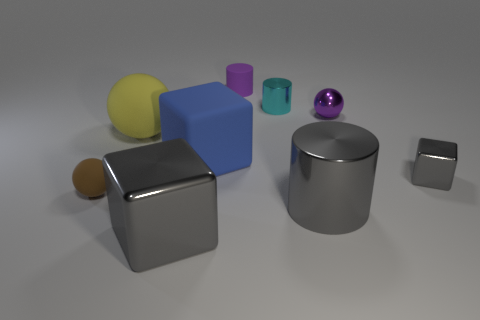Subtract all gray cubes. How many cubes are left? 1 Subtract all brown cylinders. How many gray blocks are left? 2 Subtract all blue cubes. How many cubes are left? 2 Subtract 1 blocks. How many blocks are left? 2 Add 6 matte blocks. How many matte blocks exist? 7 Subtract 0 red cubes. How many objects are left? 9 Subtract all spheres. How many objects are left? 6 Subtract all brown spheres. Subtract all red cubes. How many spheres are left? 2 Subtract all big gray shiny cylinders. Subtract all big gray metal cylinders. How many objects are left? 7 Add 8 small spheres. How many small spheres are left? 10 